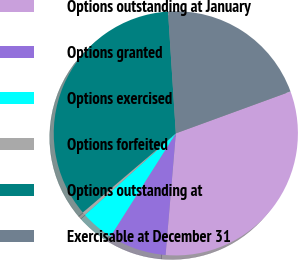Convert chart. <chart><loc_0><loc_0><loc_500><loc_500><pie_chart><fcel>Options outstanding at January<fcel>Options granted<fcel>Options exercised<fcel>Options forfeited<fcel>Options outstanding at<fcel>Exercisable at December 31<nl><fcel>31.91%<fcel>7.65%<fcel>4.38%<fcel>0.42%<fcel>35.19%<fcel>20.44%<nl></chart> 